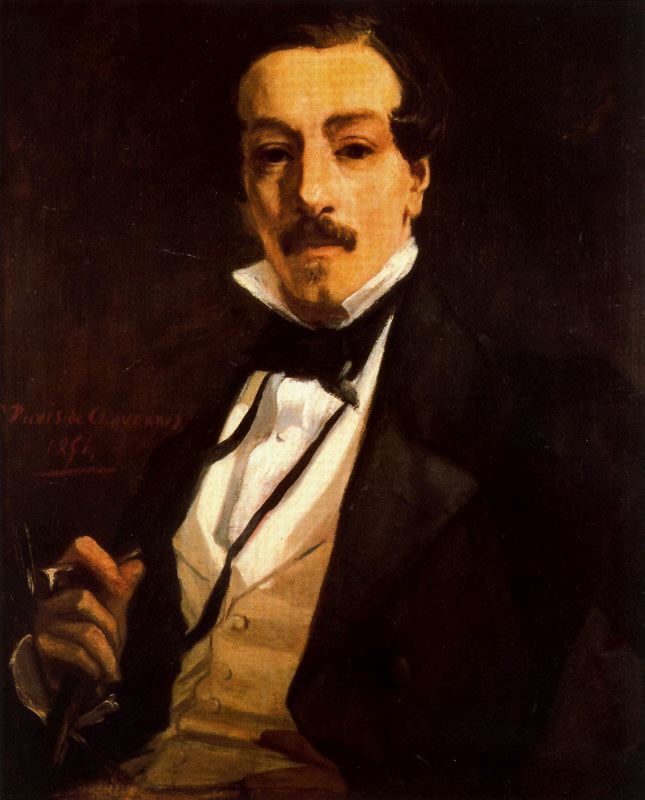What if the subject of the painting were a time traveler from the future? How would you interpret the elements of the portrait in that context? Interpreting the elements of the portrait from the perspective of the subject being a time traveler from the future introduces a fascinating narrative twist. The formal attire could be seen as an attempt to blend into the 19th-century society or as a choice to project a dignified, authoritative image across eras. The pen, traditionally a symbol of writing, might become an artifact of significant technological importance—a tool from the future disguised as an ordinary object. This pen could be capable of recording not just words, but ideas, memories, or even whole experiences, suggesting his role as a chronicler of his time-traveling adventures. The dark background might now symbolize the unknown future he has come from or the myriad timelines he navigates. His solemn expression could indicate the weight of his knowledge and the numerous experiences collected through different eras. Each element, from his attire to his pen, takes on dual meanings, playing a part in a larger story of temporal exploration and historical insight. 